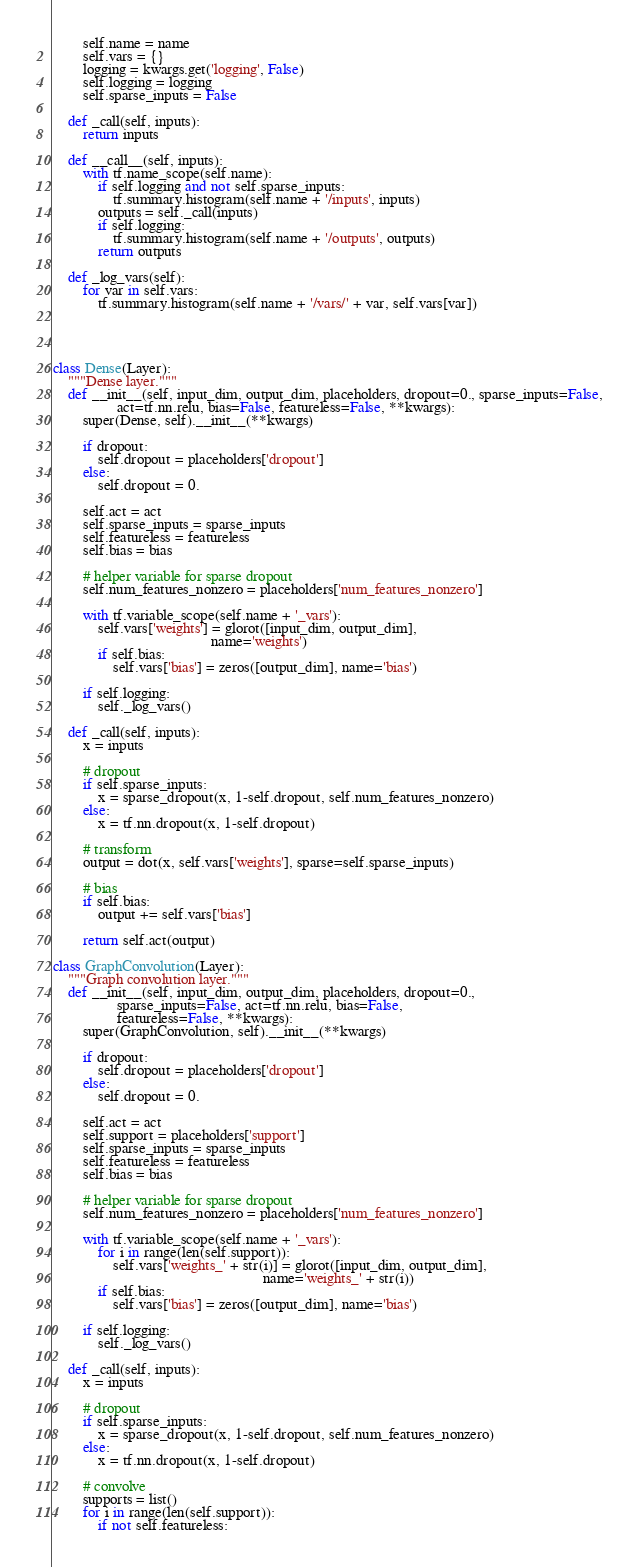<code> <loc_0><loc_0><loc_500><loc_500><_Python_>        self.name = name
        self.vars = {}
        logging = kwargs.get('logging', False)
        self.logging = logging
        self.sparse_inputs = False

    def _call(self, inputs):
        return inputs

    def __call__(self, inputs):
        with tf.name_scope(self.name):
            if self.logging and not self.sparse_inputs:
                tf.summary.histogram(self.name + '/inputs', inputs)
            outputs = self._call(inputs)
            if self.logging:
                tf.summary.histogram(self.name + '/outputs', outputs)
            return outputs

    def _log_vars(self):
        for var in self.vars:
            tf.summary.histogram(self.name + '/vars/' + var, self.vars[var])




class Dense(Layer):
    """Dense layer."""
    def __init__(self, input_dim, output_dim, placeholders, dropout=0., sparse_inputs=False,
                 act=tf.nn.relu, bias=False, featureless=False, **kwargs):
        super(Dense, self).__init__(**kwargs)

        if dropout:
            self.dropout = placeholders['dropout']
        else:
            self.dropout = 0.

        self.act = act
        self.sparse_inputs = sparse_inputs
        self.featureless = featureless
        self.bias = bias

        # helper variable for sparse dropout
        self.num_features_nonzero = placeholders['num_features_nonzero']

        with tf.variable_scope(self.name + '_vars'):
            self.vars['weights'] = glorot([input_dim, output_dim],
                                          name='weights')
            if self.bias:
                self.vars['bias'] = zeros([output_dim], name='bias')

        if self.logging:
            self._log_vars()

    def _call(self, inputs):
        x = inputs

        # dropout
        if self.sparse_inputs:
            x = sparse_dropout(x, 1-self.dropout, self.num_features_nonzero)
        else:
            x = tf.nn.dropout(x, 1-self.dropout)

        # transform
        output = dot(x, self.vars['weights'], sparse=self.sparse_inputs)

        # bias
        if self.bias:
            output += self.vars['bias']

        return self.act(output)

class GraphConvolution(Layer):
    """Graph convolution layer."""
    def __init__(self, input_dim, output_dim, placeholders, dropout=0.,
                 sparse_inputs=False, act=tf.nn.relu, bias=False,
                 featureless=False, **kwargs):
        super(GraphConvolution, self).__init__(**kwargs)

        if dropout:
            self.dropout = placeholders['dropout']
        else:
            self.dropout = 0.

        self.act = act
        self.support = placeholders['support']
        self.sparse_inputs = sparse_inputs
        self.featureless = featureless
        self.bias = bias

        # helper variable for sparse dropout
        self.num_features_nonzero = placeholders['num_features_nonzero']

        with tf.variable_scope(self.name + '_vars'):
            for i in range(len(self.support)):
                self.vars['weights_' + str(i)] = glorot([input_dim, output_dim],
                                                        name='weights_' + str(i))
            if self.bias:
                self.vars['bias'] = zeros([output_dim], name='bias')

        if self.logging:
            self._log_vars()

    def _call(self, inputs):
        x = inputs

        # dropout
        if self.sparse_inputs:
            x = sparse_dropout(x, 1-self.dropout, self.num_features_nonzero)
        else:
            x = tf.nn.dropout(x, 1-self.dropout)

        # convolve
        supports = list()
        for i in range(len(self.support)):
            if not self.featureless:</code> 